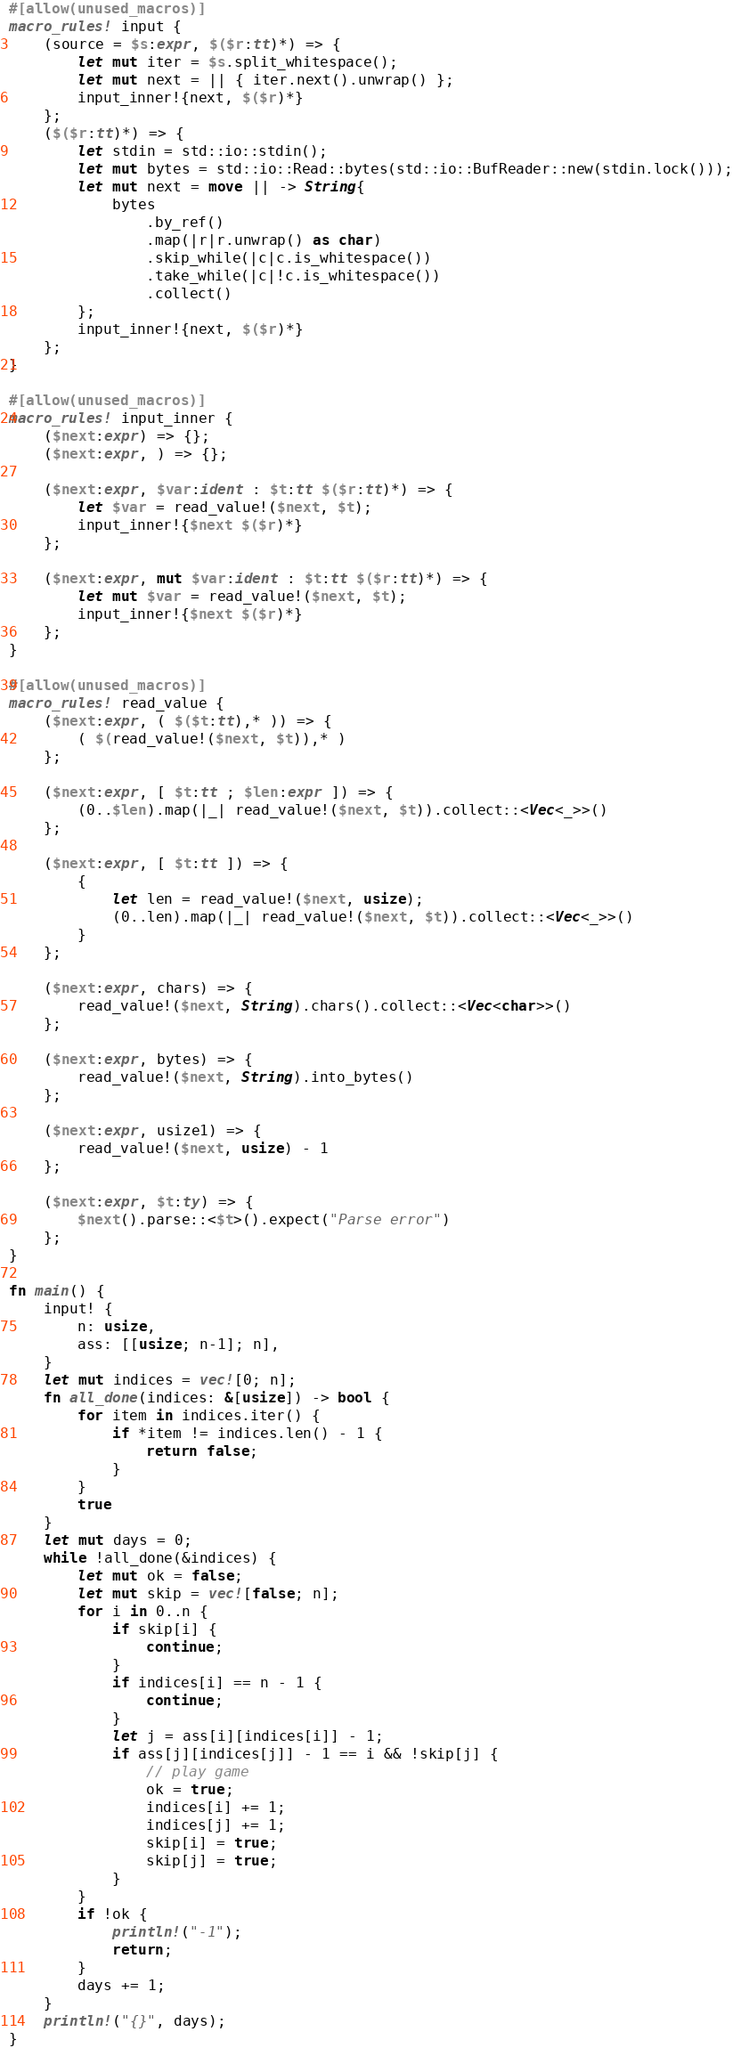<code> <loc_0><loc_0><loc_500><loc_500><_Rust_>#[allow(unused_macros)]
macro_rules! input {
    (source = $s:expr, $($r:tt)*) => {
        let mut iter = $s.split_whitespace();
        let mut next = || { iter.next().unwrap() };
        input_inner!{next, $($r)*}
    };
    ($($r:tt)*) => {
        let stdin = std::io::stdin();
        let mut bytes = std::io::Read::bytes(std::io::BufReader::new(stdin.lock()));
        let mut next = move || -> String{
            bytes
                .by_ref()
                .map(|r|r.unwrap() as char)
                .skip_while(|c|c.is_whitespace())
                .take_while(|c|!c.is_whitespace())
                .collect()
        };
        input_inner!{next, $($r)*}
    };
}

#[allow(unused_macros)]
macro_rules! input_inner {
    ($next:expr) => {};
    ($next:expr, ) => {};

    ($next:expr, $var:ident : $t:tt $($r:tt)*) => {
        let $var = read_value!($next, $t);
        input_inner!{$next $($r)*}
    };

    ($next:expr, mut $var:ident : $t:tt $($r:tt)*) => {
        let mut $var = read_value!($next, $t);
        input_inner!{$next $($r)*}
    };
}

#[allow(unused_macros)]
macro_rules! read_value {
    ($next:expr, ( $($t:tt),* )) => {
        ( $(read_value!($next, $t)),* )
    };

    ($next:expr, [ $t:tt ; $len:expr ]) => {
        (0..$len).map(|_| read_value!($next, $t)).collect::<Vec<_>>()
    };

    ($next:expr, [ $t:tt ]) => {
        {
            let len = read_value!($next, usize);
            (0..len).map(|_| read_value!($next, $t)).collect::<Vec<_>>()
        }
    };

    ($next:expr, chars) => {
        read_value!($next, String).chars().collect::<Vec<char>>()
    };

    ($next:expr, bytes) => {
        read_value!($next, String).into_bytes()
    };

    ($next:expr, usize1) => {
        read_value!($next, usize) - 1
    };

    ($next:expr, $t:ty) => {
        $next().parse::<$t>().expect("Parse error")
    };
}

fn main() {
    input! {
        n: usize,
        ass: [[usize; n-1]; n],
    }
    let mut indices = vec![0; n];
    fn all_done(indices: &[usize]) -> bool {
        for item in indices.iter() {
            if *item != indices.len() - 1 {
                return false;
            }
        }
        true
    }
    let mut days = 0;
    while !all_done(&indices) {
        let mut ok = false;
        let mut skip = vec![false; n];
        for i in 0..n {
            if skip[i] {
                continue;
            }
            if indices[i] == n - 1 {
                continue;
            }
            let j = ass[i][indices[i]] - 1;
            if ass[j][indices[j]] - 1 == i && !skip[j] {
                // play game
                ok = true;
                indices[i] += 1;
                indices[j] += 1;
                skip[i] = true;
                skip[j] = true;
            }
        }
        if !ok {
            println!("-1");
            return;
        }
        days += 1;
    }
    println!("{}", days);
}
</code> 